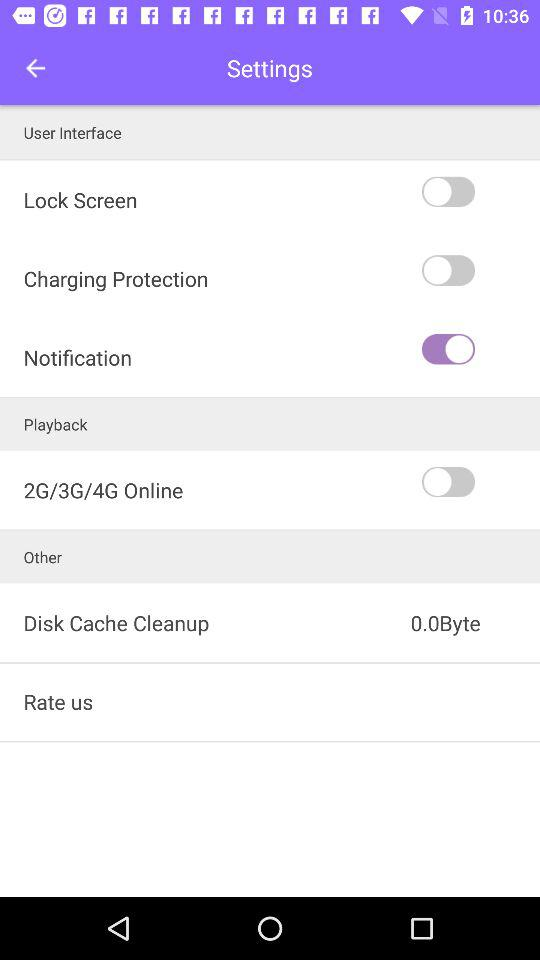What's the notification status? The status is on. 